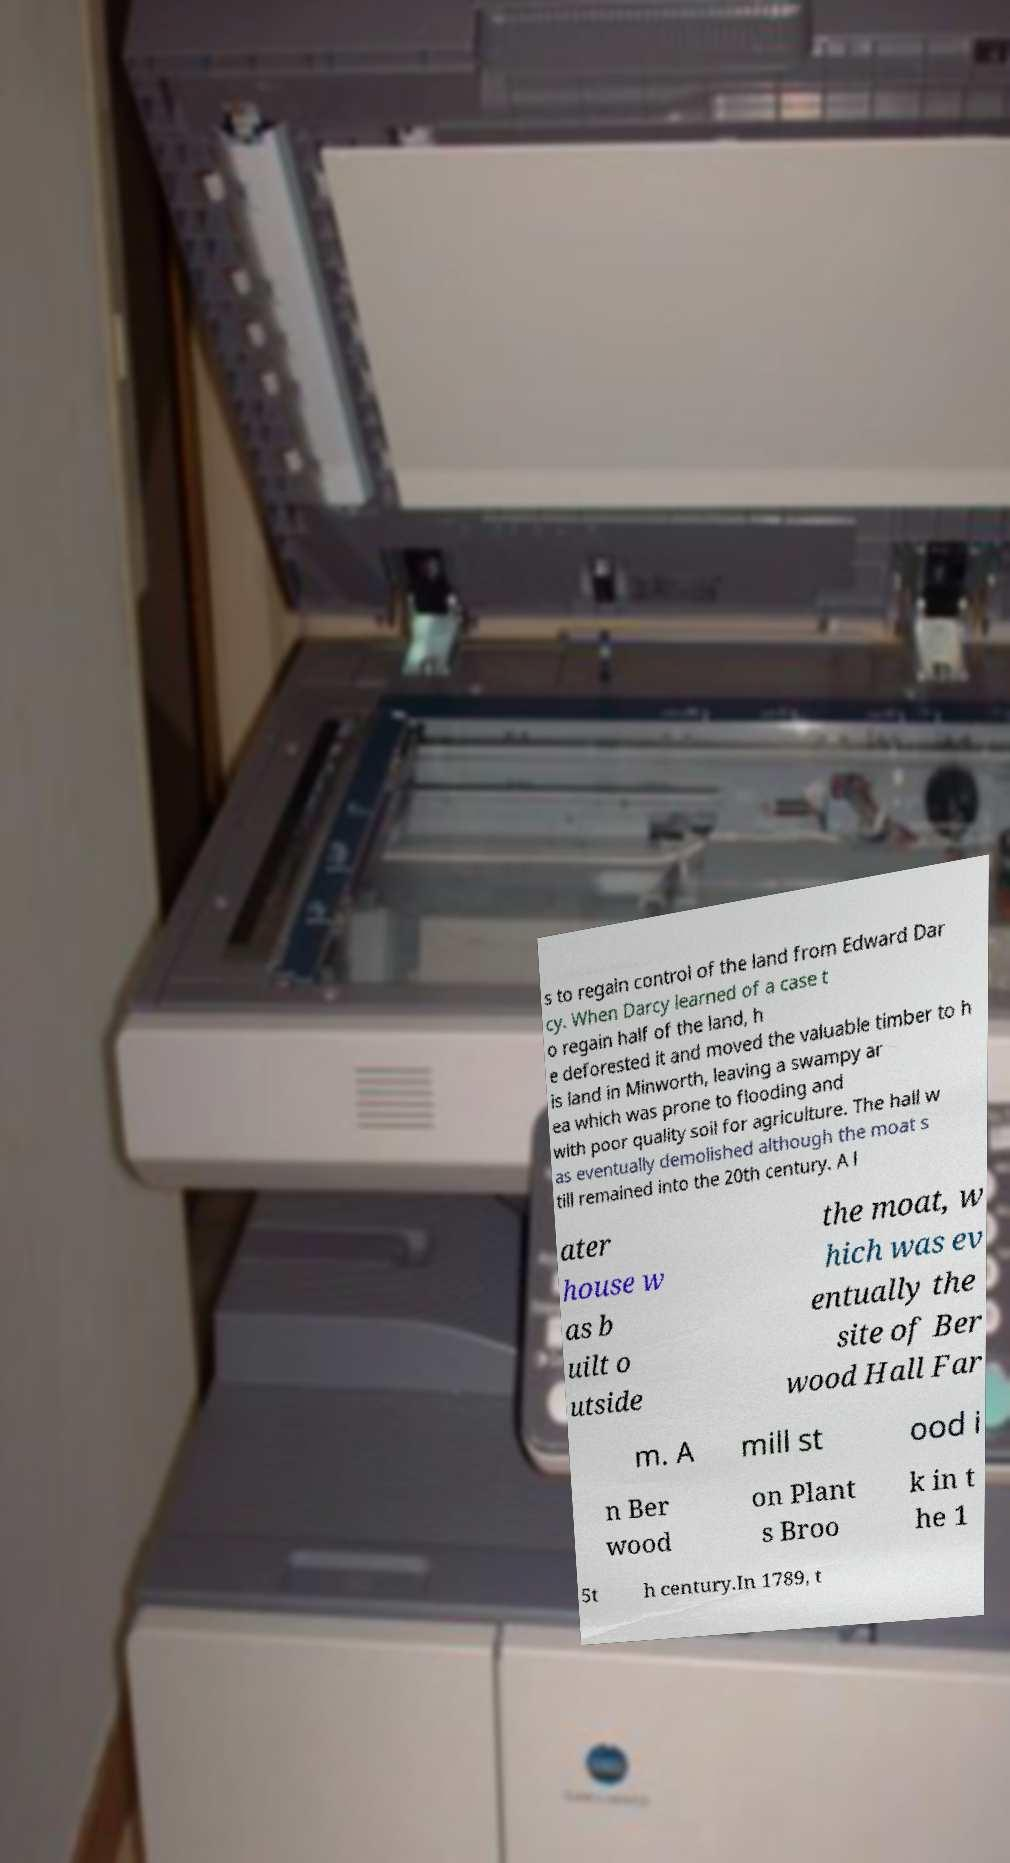For documentation purposes, I need the text within this image transcribed. Could you provide that? s to regain control of the land from Edward Dar cy. When Darcy learned of a case t o regain half of the land, h e deforested it and moved the valuable timber to h is land in Minworth, leaving a swampy ar ea which was prone to flooding and with poor quality soil for agriculture. The hall w as eventually demolished although the moat s till remained into the 20th century. A l ater house w as b uilt o utside the moat, w hich was ev entually the site of Ber wood Hall Far m. A mill st ood i n Ber wood on Plant s Broo k in t he 1 5t h century.In 1789, t 